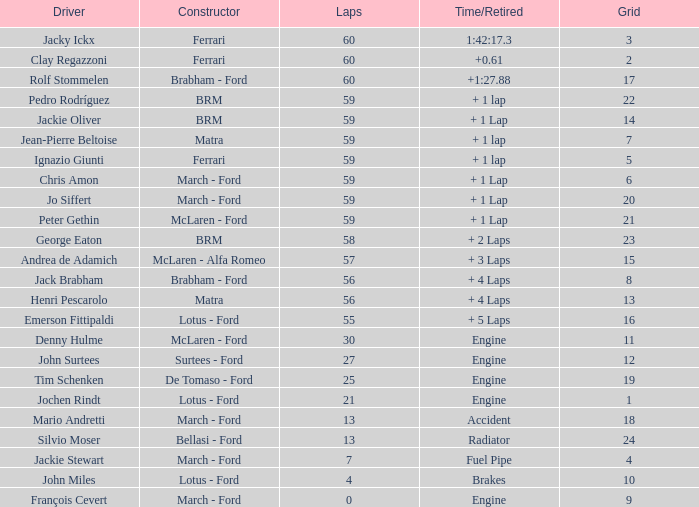Parse the table in full. {'header': ['Driver', 'Constructor', 'Laps', 'Time/Retired', 'Grid'], 'rows': [['Jacky Ickx', 'Ferrari', '60', '1:42:17.3', '3'], ['Clay Regazzoni', 'Ferrari', '60', '+0.61', '2'], ['Rolf Stommelen', 'Brabham - Ford', '60', '+1:27.88', '17'], ['Pedro Rodríguez', 'BRM', '59', '+ 1 lap', '22'], ['Jackie Oliver', 'BRM', '59', '+ 1 Lap', '14'], ['Jean-Pierre Beltoise', 'Matra', '59', '+ 1 lap', '7'], ['Ignazio Giunti', 'Ferrari', '59', '+ 1 lap', '5'], ['Chris Amon', 'March - Ford', '59', '+ 1 Lap', '6'], ['Jo Siffert', 'March - Ford', '59', '+ 1 Lap', '20'], ['Peter Gethin', 'McLaren - Ford', '59', '+ 1 Lap', '21'], ['George Eaton', 'BRM', '58', '+ 2 Laps', '23'], ['Andrea de Adamich', 'McLaren - Alfa Romeo', '57', '+ 3 Laps', '15'], ['Jack Brabham', 'Brabham - Ford', '56', '+ 4 Laps', '8'], ['Henri Pescarolo', 'Matra', '56', '+ 4 Laps', '13'], ['Emerson Fittipaldi', 'Lotus - Ford', '55', '+ 5 Laps', '16'], ['Denny Hulme', 'McLaren - Ford', '30', 'Engine', '11'], ['John Surtees', 'Surtees - Ford', '27', 'Engine', '12'], ['Tim Schenken', 'De Tomaso - Ford', '25', 'Engine', '19'], ['Jochen Rindt', 'Lotus - Ford', '21', 'Engine', '1'], ['Mario Andretti', 'March - Ford', '13', 'Accident', '18'], ['Silvio Moser', 'Bellasi - Ford', '13', 'Radiator', '24'], ['Jackie Stewart', 'March - Ford', '7', 'Fuel Pipe', '4'], ['John Miles', 'Lotus - Ford', '4', 'Brakes', '10'], ['François Cevert', 'March - Ford', '0', 'Engine', '9']]} I want the driver for grid of 9 François Cevert. 